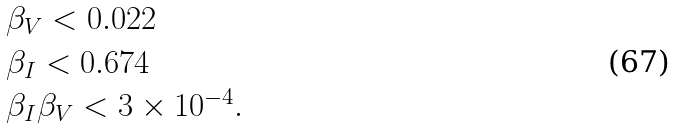Convert formula to latex. <formula><loc_0><loc_0><loc_500><loc_500>\begin{array} { l } \beta _ { V } < 0 . 0 2 2 \\ \beta _ { I } < 0 . 6 7 4 \\ \beta _ { I } \beta _ { V } < 3 \times 1 0 ^ { - 4 } . \end{array}</formula> 